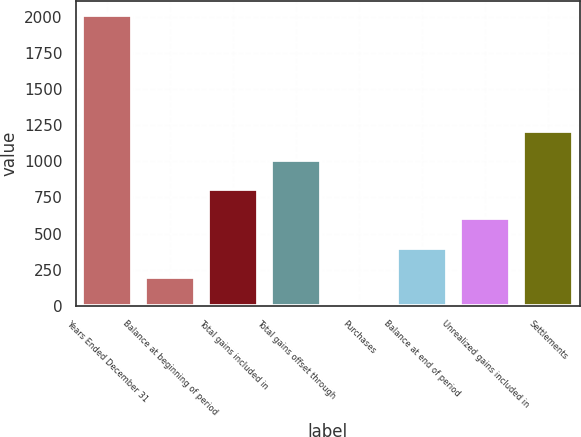Convert chart to OTSL. <chart><loc_0><loc_0><loc_500><loc_500><bar_chart><fcel>Years Ended December 31<fcel>Balance at beginning of period<fcel>Total gains included in<fcel>Total gains offset through<fcel>Purchases<fcel>Balance at end of period<fcel>Unrealized gains included in<fcel>Settlements<nl><fcel>2012<fcel>202.1<fcel>805.4<fcel>1006.5<fcel>1<fcel>403.2<fcel>604.3<fcel>1207.6<nl></chart> 